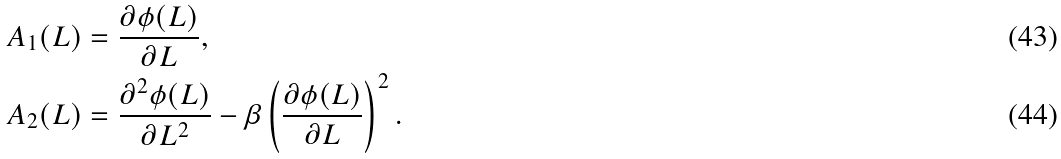<formula> <loc_0><loc_0><loc_500><loc_500>A _ { 1 } ( L ) & = \frac { \partial \phi ( L ) } { \partial L } , \\ A _ { 2 } ( L ) & = \frac { \partial ^ { 2 } \phi ( L ) } { \partial L ^ { 2 } } - \beta \left ( \frac { \partial \phi ( L ) } { \partial L } \right ) ^ { 2 } .</formula> 